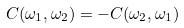Convert formula to latex. <formula><loc_0><loc_0><loc_500><loc_500>C ( \omega _ { 1 } , \omega _ { 2 } ) = - C ( \omega _ { 2 } , \omega _ { 1 } )</formula> 